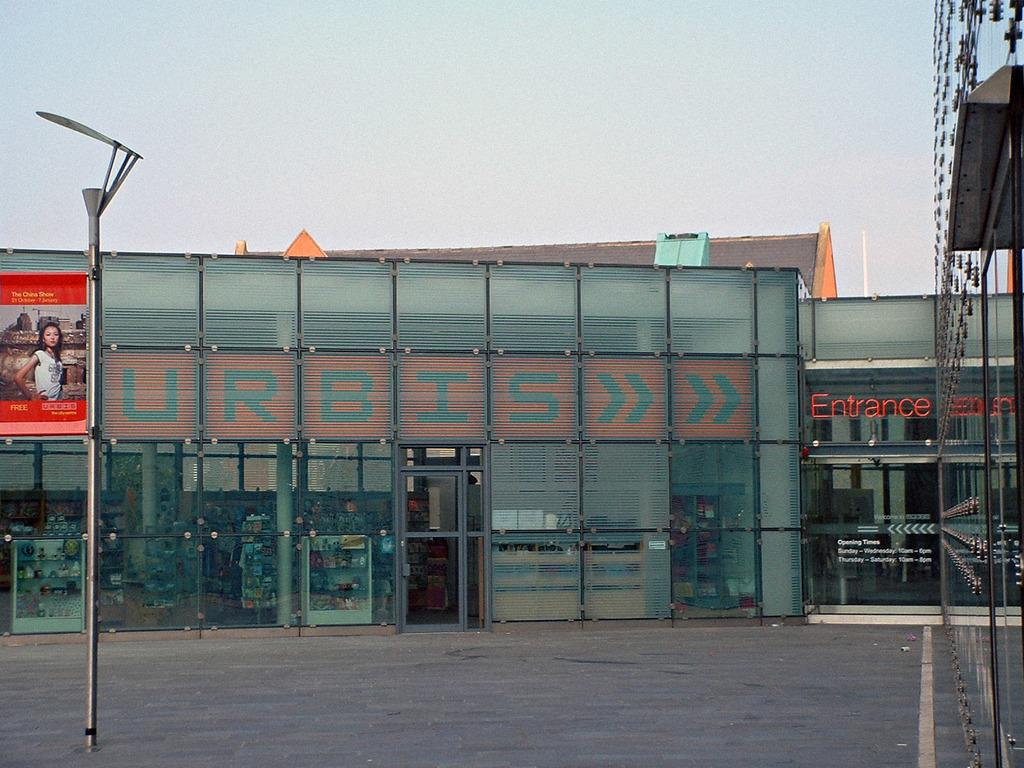What type of structure is visible in the image? There is a building in the image. What word is written on the building? The word "URBIS" is written on the building. What type of poison is being used to write the word "URBIS" on the building? There is no indication in the image that any poison is being used to write the word "URBIS" on the building. 